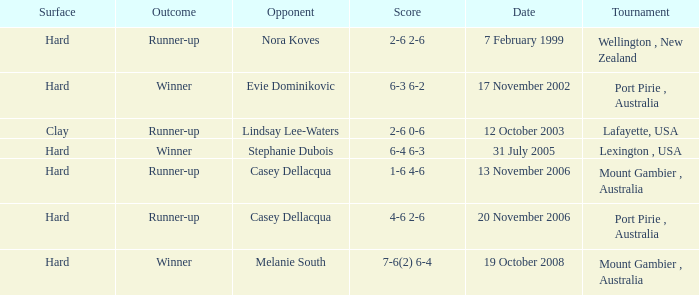Which is the Outcome on 13 november 2006? Runner-up. 